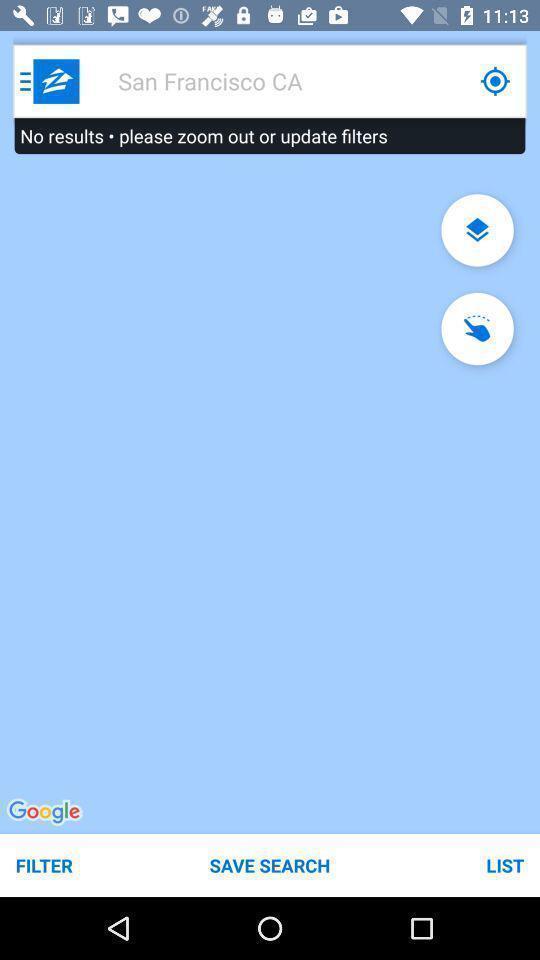What details can you identify in this image? Page displaying search option for location. 